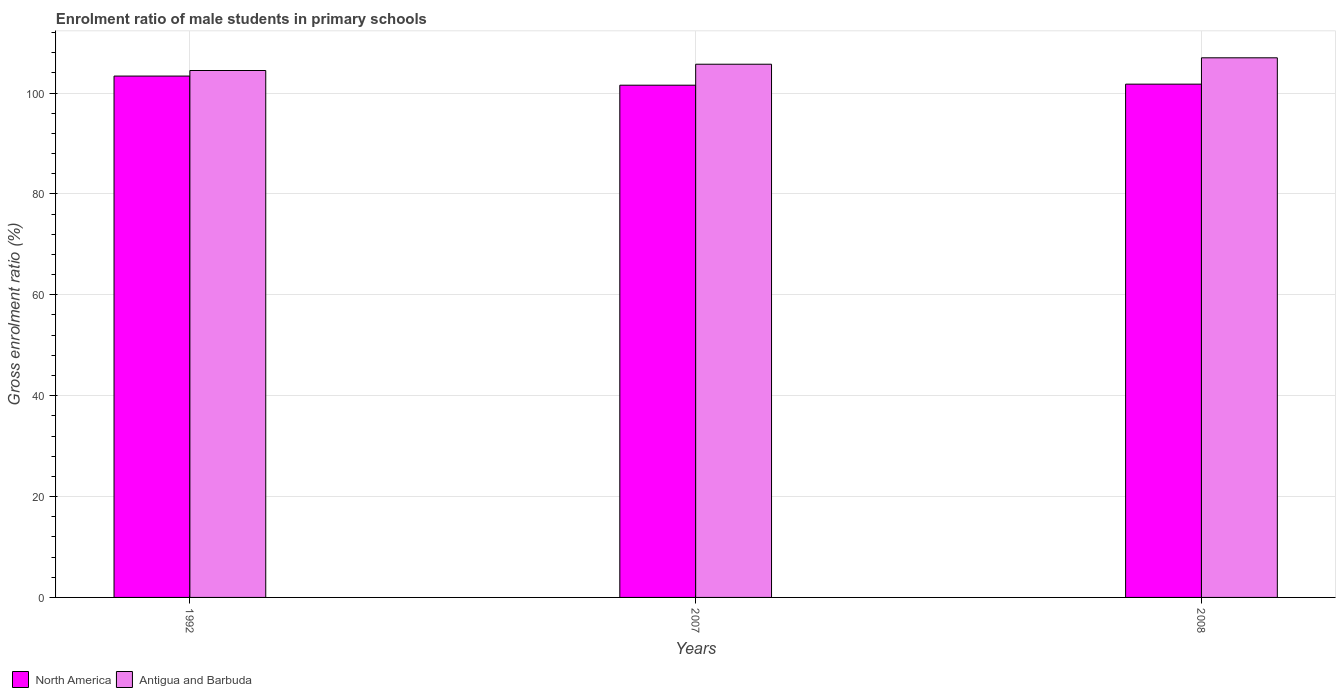How many different coloured bars are there?
Provide a short and direct response. 2. Are the number of bars per tick equal to the number of legend labels?
Provide a short and direct response. Yes. Are the number of bars on each tick of the X-axis equal?
Provide a short and direct response. Yes. How many bars are there on the 2nd tick from the right?
Offer a terse response. 2. What is the label of the 3rd group of bars from the left?
Your answer should be very brief. 2008. What is the enrolment ratio of male students in primary schools in Antigua and Barbuda in 2008?
Your answer should be compact. 106.98. Across all years, what is the maximum enrolment ratio of male students in primary schools in Antigua and Barbuda?
Ensure brevity in your answer.  106.98. Across all years, what is the minimum enrolment ratio of male students in primary schools in North America?
Give a very brief answer. 101.55. In which year was the enrolment ratio of male students in primary schools in Antigua and Barbuda minimum?
Your answer should be compact. 1992. What is the total enrolment ratio of male students in primary schools in Antigua and Barbuda in the graph?
Your response must be concise. 317.14. What is the difference between the enrolment ratio of male students in primary schools in North America in 1992 and that in 2008?
Offer a very short reply. 1.6. What is the difference between the enrolment ratio of male students in primary schools in Antigua and Barbuda in 2008 and the enrolment ratio of male students in primary schools in North America in 2007?
Make the answer very short. 5.43. What is the average enrolment ratio of male students in primary schools in Antigua and Barbuda per year?
Your answer should be very brief. 105.71. In the year 1992, what is the difference between the enrolment ratio of male students in primary schools in North America and enrolment ratio of male students in primary schools in Antigua and Barbuda?
Provide a short and direct response. -1.1. What is the ratio of the enrolment ratio of male students in primary schools in Antigua and Barbuda in 2007 to that in 2008?
Give a very brief answer. 0.99. Is the enrolment ratio of male students in primary schools in North America in 2007 less than that in 2008?
Ensure brevity in your answer.  Yes. Is the difference between the enrolment ratio of male students in primary schools in North America in 2007 and 2008 greater than the difference between the enrolment ratio of male students in primary schools in Antigua and Barbuda in 2007 and 2008?
Keep it short and to the point. Yes. What is the difference between the highest and the second highest enrolment ratio of male students in primary schools in Antigua and Barbuda?
Your answer should be very brief. 1.27. What is the difference between the highest and the lowest enrolment ratio of male students in primary schools in Antigua and Barbuda?
Your response must be concise. 2.52. Is the sum of the enrolment ratio of male students in primary schools in Antigua and Barbuda in 2007 and 2008 greater than the maximum enrolment ratio of male students in primary schools in North America across all years?
Keep it short and to the point. Yes. What does the 2nd bar from the left in 2007 represents?
Offer a terse response. Antigua and Barbuda. What does the 1st bar from the right in 2008 represents?
Ensure brevity in your answer.  Antigua and Barbuda. How many bars are there?
Provide a succinct answer. 6. How many legend labels are there?
Ensure brevity in your answer.  2. How are the legend labels stacked?
Offer a very short reply. Horizontal. What is the title of the graph?
Offer a very short reply. Enrolment ratio of male students in primary schools. What is the label or title of the X-axis?
Make the answer very short. Years. What is the Gross enrolment ratio (%) in North America in 1992?
Make the answer very short. 103.36. What is the Gross enrolment ratio (%) in Antigua and Barbuda in 1992?
Give a very brief answer. 104.46. What is the Gross enrolment ratio (%) of North America in 2007?
Keep it short and to the point. 101.55. What is the Gross enrolment ratio (%) in Antigua and Barbuda in 2007?
Give a very brief answer. 105.7. What is the Gross enrolment ratio (%) of North America in 2008?
Make the answer very short. 101.76. What is the Gross enrolment ratio (%) of Antigua and Barbuda in 2008?
Your answer should be very brief. 106.98. Across all years, what is the maximum Gross enrolment ratio (%) of North America?
Your response must be concise. 103.36. Across all years, what is the maximum Gross enrolment ratio (%) of Antigua and Barbuda?
Give a very brief answer. 106.98. Across all years, what is the minimum Gross enrolment ratio (%) in North America?
Make the answer very short. 101.55. Across all years, what is the minimum Gross enrolment ratio (%) in Antigua and Barbuda?
Provide a succinct answer. 104.46. What is the total Gross enrolment ratio (%) of North America in the graph?
Your response must be concise. 306.66. What is the total Gross enrolment ratio (%) of Antigua and Barbuda in the graph?
Ensure brevity in your answer.  317.14. What is the difference between the Gross enrolment ratio (%) of North America in 1992 and that in 2007?
Provide a succinct answer. 1.81. What is the difference between the Gross enrolment ratio (%) in Antigua and Barbuda in 1992 and that in 2007?
Provide a succinct answer. -1.24. What is the difference between the Gross enrolment ratio (%) of North America in 1992 and that in 2008?
Ensure brevity in your answer.  1.6. What is the difference between the Gross enrolment ratio (%) in Antigua and Barbuda in 1992 and that in 2008?
Offer a very short reply. -2.52. What is the difference between the Gross enrolment ratio (%) in North America in 2007 and that in 2008?
Keep it short and to the point. -0.21. What is the difference between the Gross enrolment ratio (%) of Antigua and Barbuda in 2007 and that in 2008?
Ensure brevity in your answer.  -1.27. What is the difference between the Gross enrolment ratio (%) of North America in 1992 and the Gross enrolment ratio (%) of Antigua and Barbuda in 2007?
Offer a very short reply. -2.35. What is the difference between the Gross enrolment ratio (%) of North America in 1992 and the Gross enrolment ratio (%) of Antigua and Barbuda in 2008?
Keep it short and to the point. -3.62. What is the difference between the Gross enrolment ratio (%) in North America in 2007 and the Gross enrolment ratio (%) in Antigua and Barbuda in 2008?
Keep it short and to the point. -5.43. What is the average Gross enrolment ratio (%) in North America per year?
Your answer should be compact. 102.22. What is the average Gross enrolment ratio (%) of Antigua and Barbuda per year?
Your answer should be very brief. 105.71. In the year 1992, what is the difference between the Gross enrolment ratio (%) in North America and Gross enrolment ratio (%) in Antigua and Barbuda?
Your answer should be very brief. -1.1. In the year 2007, what is the difference between the Gross enrolment ratio (%) in North America and Gross enrolment ratio (%) in Antigua and Barbuda?
Provide a short and direct response. -4.16. In the year 2008, what is the difference between the Gross enrolment ratio (%) in North America and Gross enrolment ratio (%) in Antigua and Barbuda?
Ensure brevity in your answer.  -5.22. What is the ratio of the Gross enrolment ratio (%) in North America in 1992 to that in 2007?
Make the answer very short. 1.02. What is the ratio of the Gross enrolment ratio (%) in North America in 1992 to that in 2008?
Provide a short and direct response. 1.02. What is the ratio of the Gross enrolment ratio (%) of Antigua and Barbuda in 1992 to that in 2008?
Provide a short and direct response. 0.98. What is the difference between the highest and the second highest Gross enrolment ratio (%) of North America?
Your answer should be compact. 1.6. What is the difference between the highest and the second highest Gross enrolment ratio (%) in Antigua and Barbuda?
Provide a short and direct response. 1.27. What is the difference between the highest and the lowest Gross enrolment ratio (%) in North America?
Provide a short and direct response. 1.81. What is the difference between the highest and the lowest Gross enrolment ratio (%) in Antigua and Barbuda?
Your response must be concise. 2.52. 